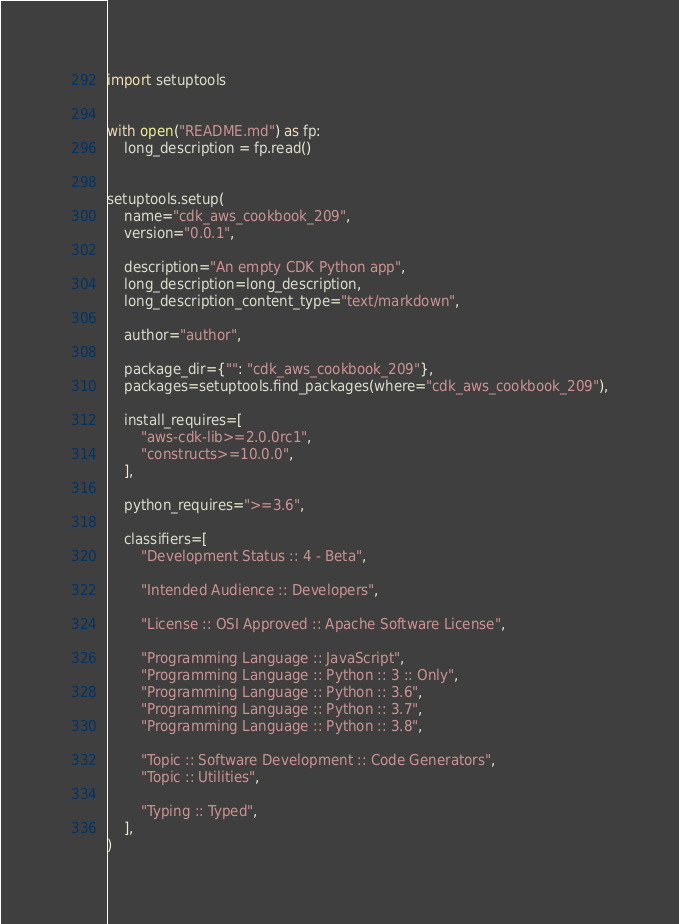Convert code to text. <code><loc_0><loc_0><loc_500><loc_500><_Python_>import setuptools


with open("README.md") as fp:
    long_description = fp.read()


setuptools.setup(
    name="cdk_aws_cookbook_209",
    version="0.0.1",

    description="An empty CDK Python app",
    long_description=long_description,
    long_description_content_type="text/markdown",

    author="author",

    package_dir={"": "cdk_aws_cookbook_209"},
    packages=setuptools.find_packages(where="cdk_aws_cookbook_209"),

    install_requires=[
        "aws-cdk-lib>=2.0.0rc1",
        "constructs>=10.0.0",
    ],

    python_requires=">=3.6",

    classifiers=[
        "Development Status :: 4 - Beta",

        "Intended Audience :: Developers",

        "License :: OSI Approved :: Apache Software License",

        "Programming Language :: JavaScript",
        "Programming Language :: Python :: 3 :: Only",
        "Programming Language :: Python :: 3.6",
        "Programming Language :: Python :: 3.7",
        "Programming Language :: Python :: 3.8",

        "Topic :: Software Development :: Code Generators",
        "Topic :: Utilities",

        "Typing :: Typed",
    ],
)
</code> 